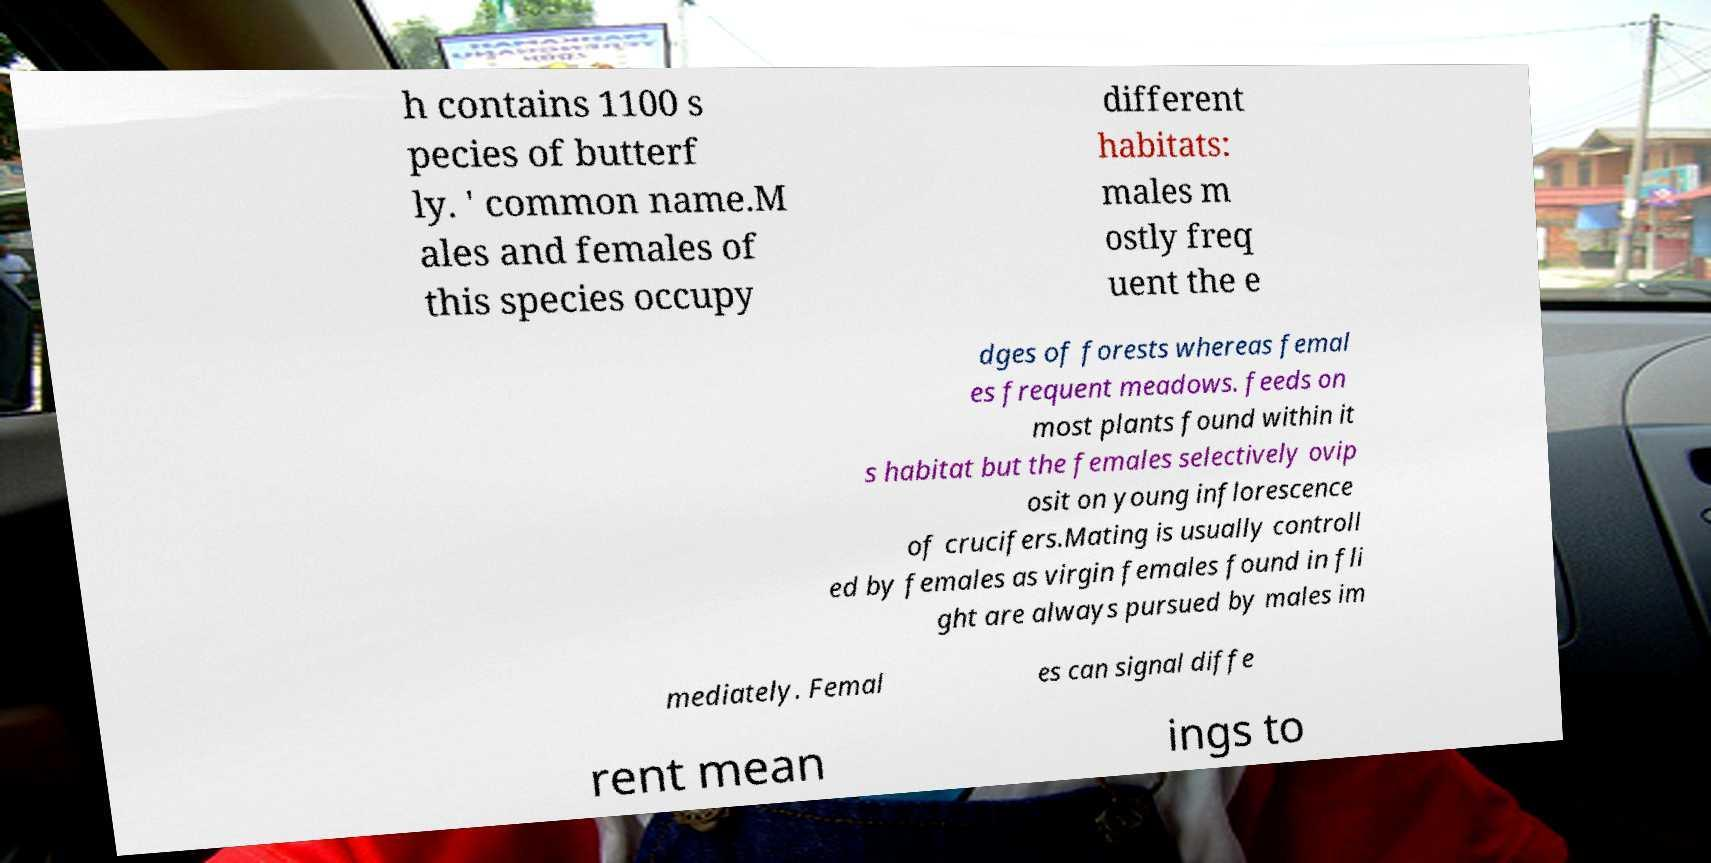Please read and relay the text visible in this image. What does it say? h contains 1100 s pecies of butterf ly. ' common name.M ales and females of this species occupy different habitats: males m ostly freq uent the e dges of forests whereas femal es frequent meadows. feeds on most plants found within it s habitat but the females selectively ovip osit on young inflorescence of crucifers.Mating is usually controll ed by females as virgin females found in fli ght are always pursued by males im mediately. Femal es can signal diffe rent mean ings to 